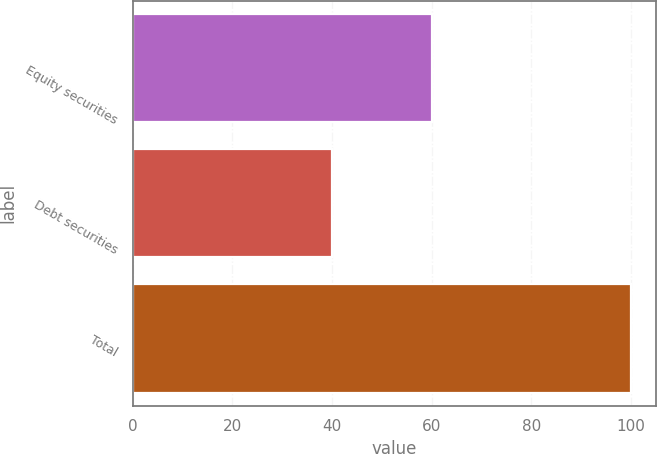Convert chart. <chart><loc_0><loc_0><loc_500><loc_500><bar_chart><fcel>Equity securities<fcel>Debt securities<fcel>Total<nl><fcel>60<fcel>40<fcel>100<nl></chart> 